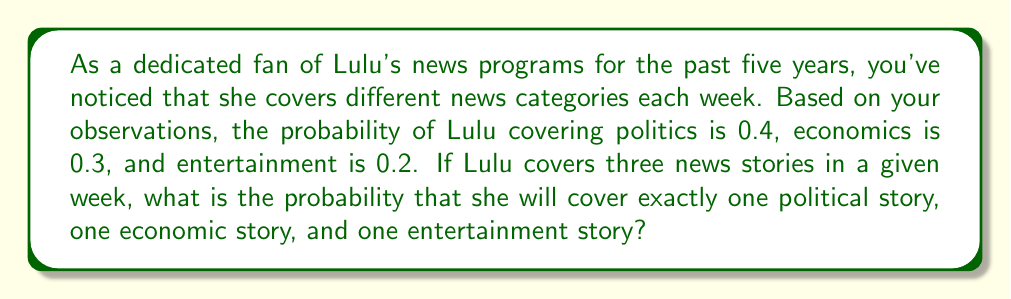Can you solve this math problem? To solve this problem, we need to use the concept of probability and the multiplication rule for independent events. Let's break it down step by step:

1) First, we need to calculate the probability of covering other categories:
   $P(\text{other}) = 1 - (0.4 + 0.3 + 0.2) = 0.1$

2) Now, we need to find the probability of this specific combination:
   - One political story (P)
   - One economic story (E)
   - One entertainment story (T)

3) The order of these stories doesn't matter, so we need to consider all possible arrangements:
   (P, E, T), (P, T, E), (E, P, T), (E, T, P), (T, P, E), (T, E, P)

4) There are 6 possible arrangements, and each has the same probability. We can calculate the probability of one arrangement and multiply by 6.

5) For one arrangement, say (P, E, T), the probability is:
   $P(\text{P, E, T}) = 0.4 \times 0.3 \times 0.2 = 0.024$

6) Therefore, the total probability is:
   $P(\text{exactly one of each}) = 6 \times 0.024 = 0.144$

This can also be calculated using the multinomial probability formula:

$$P(X_1 = 1, X_2 = 1, X_3 = 1) = \frac{3!}{1!1!1!} \times 0.4^1 \times 0.3^1 \times 0.2^1 = 6 \times 0.024 = 0.144$$
Answer: The probability that Lulu will cover exactly one political story, one economic story, and one entertainment story in a given week is 0.144 or 14.4%. 